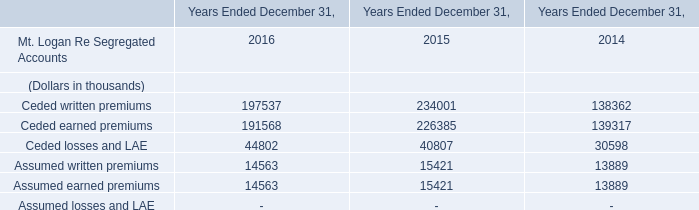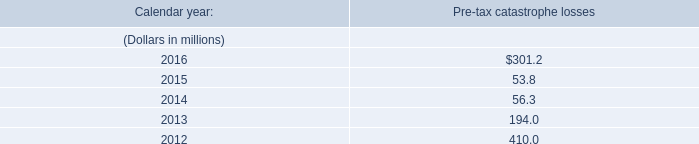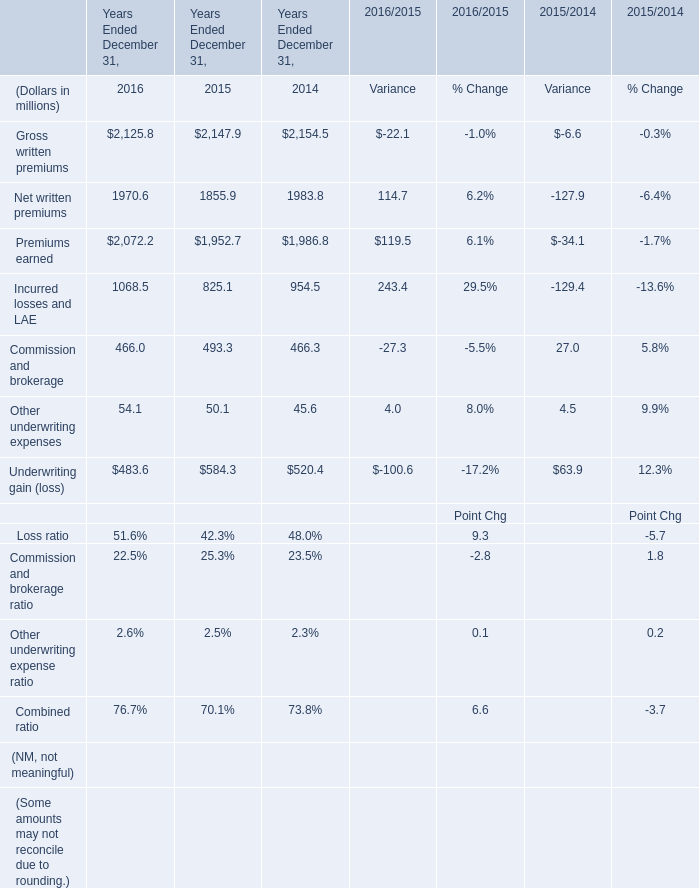what's the total amount of Gross written premiums of Years Ended December 31, 2014, and Assumed written premiums of Years Ended December 31, 2015 ? 
Computations: (2154.5 + 15421.0)
Answer: 17575.5. 